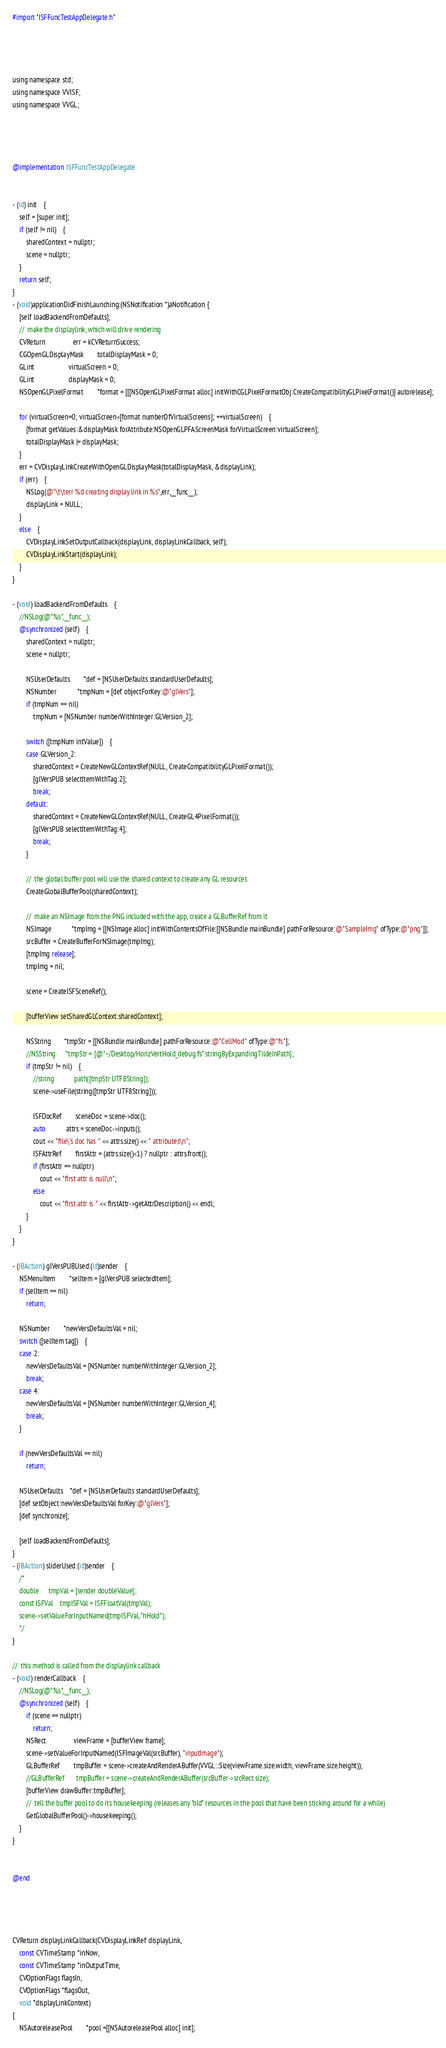<code> <loc_0><loc_0><loc_500><loc_500><_ObjectiveC_>#import "ISFFuncTestAppDelegate.h"




using namespace std;
using namespace VVISF;
using namespace VVGL;




@implementation ISFFuncTestAppDelegate


- (id) init	{
	self = [super init];
	if (self != nil)	{
		sharedContext = nullptr;
		scene = nullptr;
	}
	return self;
}
- (void)applicationDidFinishLaunching:(NSNotification *)aNotification {
	[self loadBackendFromDefaults];
	//	make the displaylink, which will drive rendering
	CVReturn				err = kCVReturnSuccess;
	CGOpenGLDisplayMask		totalDisplayMask = 0;
	GLint					virtualScreen = 0;
	GLint					displayMask = 0;
	NSOpenGLPixelFormat		*format = [[[NSOpenGLPixelFormat alloc] initWithCGLPixelFormatObj:CreateCompatibilityGLPixelFormat()] autorelease];
	
	for (virtualScreen=0; virtualScreen<[format numberOfVirtualScreens]; ++virtualScreen)	{
		[format getValues:&displayMask forAttribute:NSOpenGLPFAScreenMask forVirtualScreen:virtualScreen];
		totalDisplayMask |= displayMask;
	}
	err = CVDisplayLinkCreateWithOpenGLDisplayMask(totalDisplayMask, &displayLink);
	if (err)	{
		NSLog(@"\t\terr %d creating display link in %s",err,__func__);
		displayLink = NULL;
	}
	else	{
		CVDisplayLinkSetOutputCallback(displayLink, displayLinkCallback, self);
		CVDisplayLinkStart(displayLink);
	}
}

- (void) loadBackendFromDefaults	{
	//NSLog(@"%s",__func__);
	@synchronized (self)	{
		sharedContext = nullptr;
		scene = nullptr;
	
		NSUserDefaults		*def = [NSUserDefaults standardUserDefaults];
		NSNumber			*tmpNum = [def objectForKey:@"glVers"];
		if (tmpNum == nil)
			tmpNum = [NSNumber numberWithInteger:GLVersion_2];
	
		switch ([tmpNum intValue])	{
		case GLVersion_2:
			sharedContext = CreateNewGLContextRef(NULL, CreateCompatibilityGLPixelFormat());
			[glVersPUB selectItemWithTag:2];
			break;
		default:
			sharedContext = CreateNewGLContextRef(NULL, CreateGL4PixelFormat());
			[glVersPUB selectItemWithTag:4];
			break;
		}
		
		//	the global buffer pool will use the shared context to create any GL resources
		CreateGlobalBufferPool(sharedContext);
		
		//	make an NSImage from the PNG included with the app, create a GLBufferRef from it
		NSImage			*tmpImg = [[NSImage alloc] initWithContentsOfFile:[[NSBundle mainBundle] pathForResource:@"SampleImg" ofType:@"png"]];
		srcBuffer = CreateBufferForNSImage(tmpImg);
		[tmpImg release];
		tmpImg = nil;
	
		scene = CreateISFSceneRef();
	
		[bufferView setSharedGLContext:sharedContext];
	
		NSString		*tmpStr = [[NSBundle mainBundle] pathForResource:@"CellMod" ofType:@"fs"];
		//NSString		*tmpStr = [@"~/Desktop/HorizVertHold_debug.fs" stringByExpandingTildeInPath];
		if (tmpStr != nil)	{
			//string			path([tmpStr UTF8String]);
			scene->useFile(string([tmpStr UTF8String]));
			
			ISFDocRef		sceneDoc = scene->doc();
			auto			attrs = sceneDoc->inputs();
			cout << "file\'s doc has " << attrs.size() << " attributes\n";
			ISFAttrRef		firstAttr = (attrs.size()<1) ? nullptr : attrs.front();
			if (firstAttr == nullptr)
				cout << "first attr is null\n";
			else
				cout << "first attr is " << firstAttr->getAttrDescription() << endl;
		}
	}
}

- (IBAction) glVersPUBUsed:(id)sender	{
	NSMenuItem		*selItem = [glVersPUB selectedItem];
	if (selItem == nil)
		return;
	
	NSNumber		*newVersDefaultsVal = nil;
	switch ([selItem tag])	{
	case 2:
		newVersDefaultsVal = [NSNumber numberWithInteger:GLVersion_2];
		break;
	case 4:
		newVersDefaultsVal = [NSNumber numberWithInteger:GLVersion_4];
		break;
	}
	
	if (newVersDefaultsVal == nil)
		return;
	
	NSUserDefaults	*def = [NSUserDefaults standardUserDefaults];
	[def setObject:newVersDefaultsVal forKey:@"glVers"];
	[def synchronize];
	
	[self loadBackendFromDefaults];
}
- (IBAction) sliderUsed:(id)sender	{
	/*
	double		tmpVal = [sender doubleValue];
	const ISFVal	tmpISFVal = ISFFloatVal(tmpVal);
	scene->setValueForInputNamed(tmpISFVal, "hHold");
	*/
}

//	this method is called from the displaylink callback
- (void) renderCallback	{
	//NSLog(@"%s",__func__);
	@synchronized (self)	{
		if (scene == nullptr)
			return;
		NSRect				viewFrame = [bufferView frame];
		scene->setValueForInputNamed(ISFImageVal(srcBuffer), "inputImage");
		GLBufferRef		tmpBuffer = scene->createAndRenderABuffer(VVGL::Size(viewFrame.size.width, viewFrame.size.height));
		//GLBufferRef		tmpBuffer = scene->createAndRenderABuffer(srcBuffer->srcRect.size);
		[bufferView drawBuffer:tmpBuffer];
		//	tell the buffer pool to do its housekeeping (releases any "old" resources in the pool that have been sticking around for a while)
		GetGlobalBufferPool()->housekeeping();
	}
}


@end




CVReturn displayLinkCallback(CVDisplayLinkRef displayLink, 
	const CVTimeStamp *inNow, 
	const CVTimeStamp *inOutputTime, 
	CVOptionFlags flagsIn, 
	CVOptionFlags *flagsOut, 
	void *displayLinkContext)
{
	NSAutoreleasePool		*pool =[[NSAutoreleasePool alloc] init];</code> 